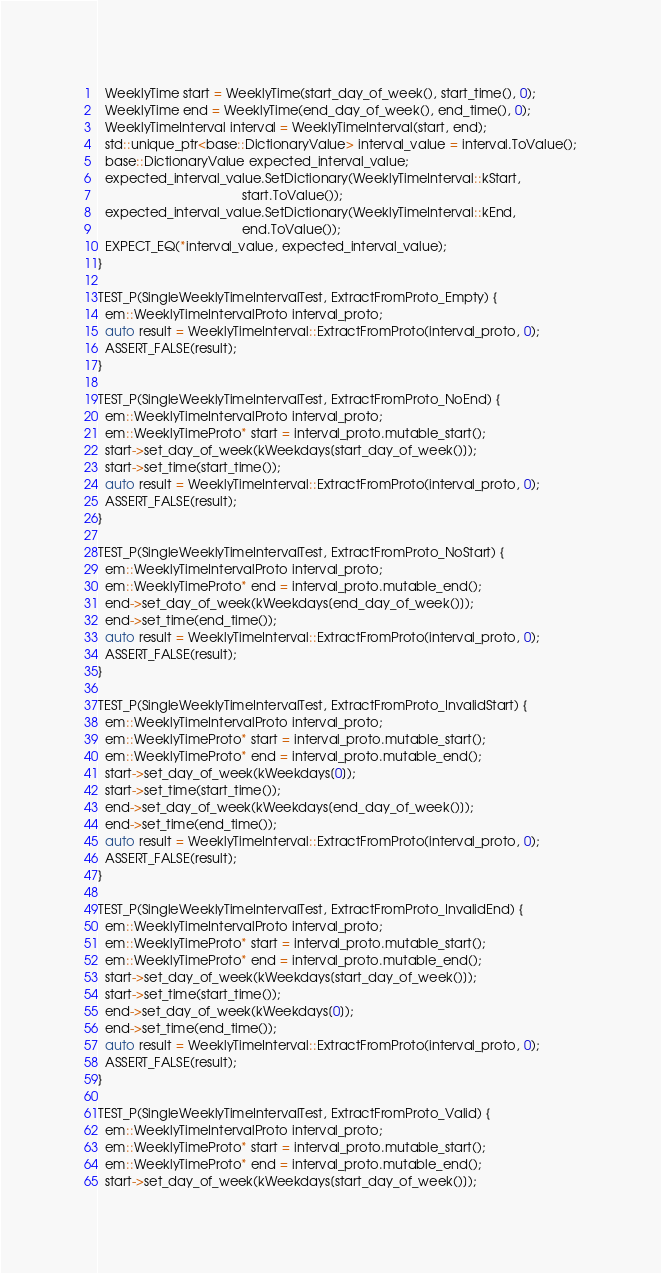Convert code to text. <code><loc_0><loc_0><loc_500><loc_500><_C++_>  WeeklyTime start = WeeklyTime(start_day_of_week(), start_time(), 0);
  WeeklyTime end = WeeklyTime(end_day_of_week(), end_time(), 0);
  WeeklyTimeInterval interval = WeeklyTimeInterval(start, end);
  std::unique_ptr<base::DictionaryValue> interval_value = interval.ToValue();
  base::DictionaryValue expected_interval_value;
  expected_interval_value.SetDictionary(WeeklyTimeInterval::kStart,
                                        start.ToValue());
  expected_interval_value.SetDictionary(WeeklyTimeInterval::kEnd,
                                        end.ToValue());
  EXPECT_EQ(*interval_value, expected_interval_value);
}

TEST_P(SingleWeeklyTimeIntervalTest, ExtractFromProto_Empty) {
  em::WeeklyTimeIntervalProto interval_proto;
  auto result = WeeklyTimeInterval::ExtractFromProto(interval_proto, 0);
  ASSERT_FALSE(result);
}

TEST_P(SingleWeeklyTimeIntervalTest, ExtractFromProto_NoEnd) {
  em::WeeklyTimeIntervalProto interval_proto;
  em::WeeklyTimeProto* start = interval_proto.mutable_start();
  start->set_day_of_week(kWeekdays[start_day_of_week()]);
  start->set_time(start_time());
  auto result = WeeklyTimeInterval::ExtractFromProto(interval_proto, 0);
  ASSERT_FALSE(result);
}

TEST_P(SingleWeeklyTimeIntervalTest, ExtractFromProto_NoStart) {
  em::WeeklyTimeIntervalProto interval_proto;
  em::WeeklyTimeProto* end = interval_proto.mutable_end();
  end->set_day_of_week(kWeekdays[end_day_of_week()]);
  end->set_time(end_time());
  auto result = WeeklyTimeInterval::ExtractFromProto(interval_proto, 0);
  ASSERT_FALSE(result);
}

TEST_P(SingleWeeklyTimeIntervalTest, ExtractFromProto_InvalidStart) {
  em::WeeklyTimeIntervalProto interval_proto;
  em::WeeklyTimeProto* start = interval_proto.mutable_start();
  em::WeeklyTimeProto* end = interval_proto.mutable_end();
  start->set_day_of_week(kWeekdays[0]);
  start->set_time(start_time());
  end->set_day_of_week(kWeekdays[end_day_of_week()]);
  end->set_time(end_time());
  auto result = WeeklyTimeInterval::ExtractFromProto(interval_proto, 0);
  ASSERT_FALSE(result);
}

TEST_P(SingleWeeklyTimeIntervalTest, ExtractFromProto_InvalidEnd) {
  em::WeeklyTimeIntervalProto interval_proto;
  em::WeeklyTimeProto* start = interval_proto.mutable_start();
  em::WeeklyTimeProto* end = interval_proto.mutable_end();
  start->set_day_of_week(kWeekdays[start_day_of_week()]);
  start->set_time(start_time());
  end->set_day_of_week(kWeekdays[0]);
  end->set_time(end_time());
  auto result = WeeklyTimeInterval::ExtractFromProto(interval_proto, 0);
  ASSERT_FALSE(result);
}

TEST_P(SingleWeeklyTimeIntervalTest, ExtractFromProto_Valid) {
  em::WeeklyTimeIntervalProto interval_proto;
  em::WeeklyTimeProto* start = interval_proto.mutable_start();
  em::WeeklyTimeProto* end = interval_proto.mutable_end();
  start->set_day_of_week(kWeekdays[start_day_of_week()]);</code> 